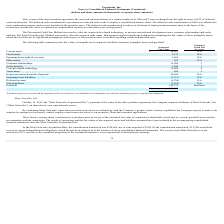According to Proofpoint's financial document, How did Proofpoint Inc make it easier for enterprises to accurately control employees and contractor access to on-premises, cloud and consumer application?   combining Meta Networks’ innovative zero trust network access technology with the Company’s people-centric security capabilities. The document states: "By combining Meta Networks’ innovative zero trust network access technology with the Company’s people-centric security capabilities the Company expect..." Also, What method was used to value the acquired technology, in-process research and development assests?  Discounted Cash Flow Method. The document states: "The Discounted Cash Flow Method was used to value the acquired developed technology, in-process research and development asset, cus..." Also, Which subject has the highest estimated useful life? According to the financial document, Goodwill. The relevant text states: "Goodwill 144,374 Indefinite..." Also, can you calculate: What is the difference in estimated fair value between current assets and fixed assets? Based on the calculation: $10,603 - 2,132, the result is 8471 (in thousands). This is based on the information: "Current assets $ 10,603 N/A Fixed assets 2,132 N/A..." The key data points involved are: 10,603, 2,132. Also, can you calculate: What is the average estimated fair value of Customer relationships? Based on the calculation: 15,800 / 5, the result is 3160 (in thousands). This is based on the information: "Customer relationships 15,800 5 Customer relationships 15,800 5..." The key data points involved are: 15,800, 5. Also, can you calculate: What is the total estimated fair value of all assets? Based on the calculation: $10,603 + 2,132 + 2,669 + 652 + 15,800 + 1,300 + 35,400 + 400 + 20,600, the result is 89556 (in thousands). This is based on the information: "Current assets $ 10,603 N/A Fixed assets 2,132 N/A In-process research and development * 20,600 N/A Core/developed technology 35,400 4 Operating lease right-of-use asset 2,669 N/A Customer relationshi..." The key data points involved are: 1,300, 10,603, 15,800. 